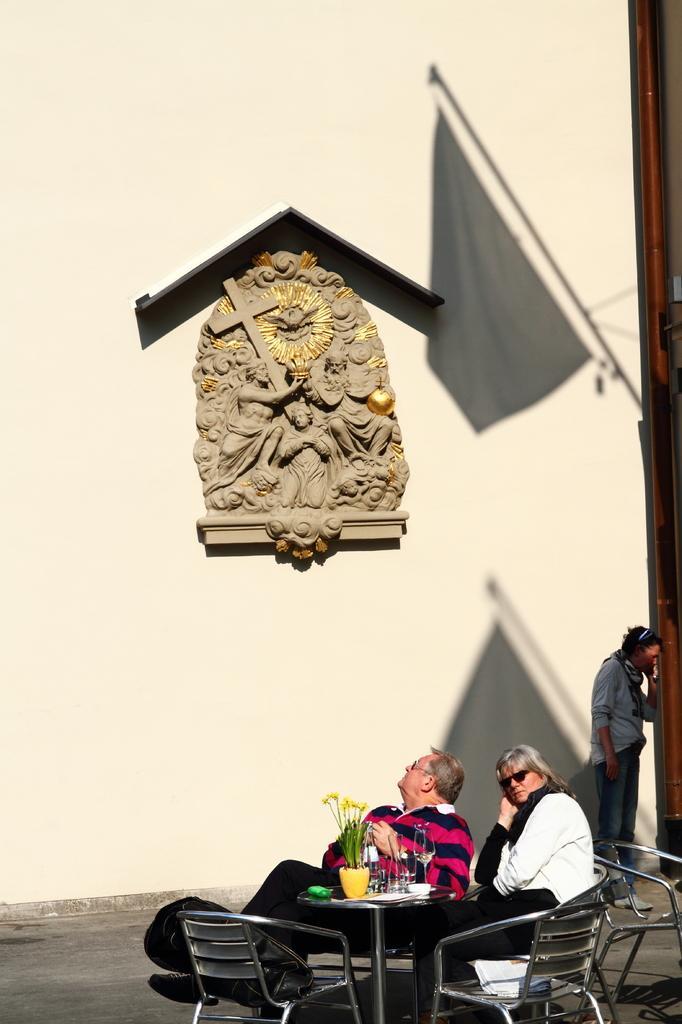How would you summarize this image in a sentence or two? In this picture we can see two persons sitting on chairs, there is a bag here, in the background we can see a person standing, in the background there is a wall, we can see a shadow here, there is a Christianity symbol here. 